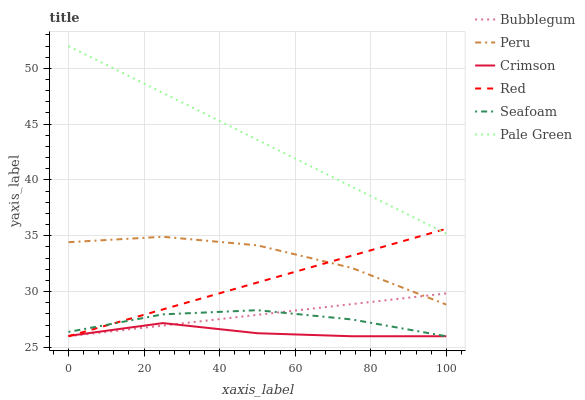Does Crimson have the minimum area under the curve?
Answer yes or no. Yes. Does Pale Green have the maximum area under the curve?
Answer yes or no. Yes. Does Bubblegum have the minimum area under the curve?
Answer yes or no. No. Does Bubblegum have the maximum area under the curve?
Answer yes or no. No. Is Bubblegum the smoothest?
Answer yes or no. Yes. Is Peru the roughest?
Answer yes or no. Yes. Is Pale Green the smoothest?
Answer yes or no. No. Is Pale Green the roughest?
Answer yes or no. No. Does Seafoam have the lowest value?
Answer yes or no. Yes. Does Pale Green have the lowest value?
Answer yes or no. No. Does Pale Green have the highest value?
Answer yes or no. Yes. Does Bubblegum have the highest value?
Answer yes or no. No. Is Peru less than Pale Green?
Answer yes or no. Yes. Is Pale Green greater than Seafoam?
Answer yes or no. Yes. Does Peru intersect Bubblegum?
Answer yes or no. Yes. Is Peru less than Bubblegum?
Answer yes or no. No. Is Peru greater than Bubblegum?
Answer yes or no. No. Does Peru intersect Pale Green?
Answer yes or no. No. 